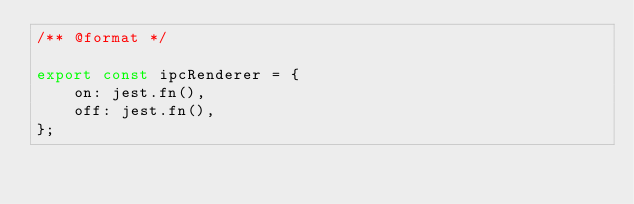<code> <loc_0><loc_0><loc_500><loc_500><_JavaScript_>/** @format */

export const ipcRenderer = {
	on: jest.fn(),
	off: jest.fn(),
};
</code> 